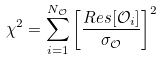Convert formula to latex. <formula><loc_0><loc_0><loc_500><loc_500>\chi ^ { 2 } = \sum _ { i = 1 } ^ { N _ { \mathcal { O } } } \left [ \frac { R e s [ \mathcal { O } _ { i } ] } { \sigma _ { \mathcal { O } } } \right ] ^ { 2 }</formula> 